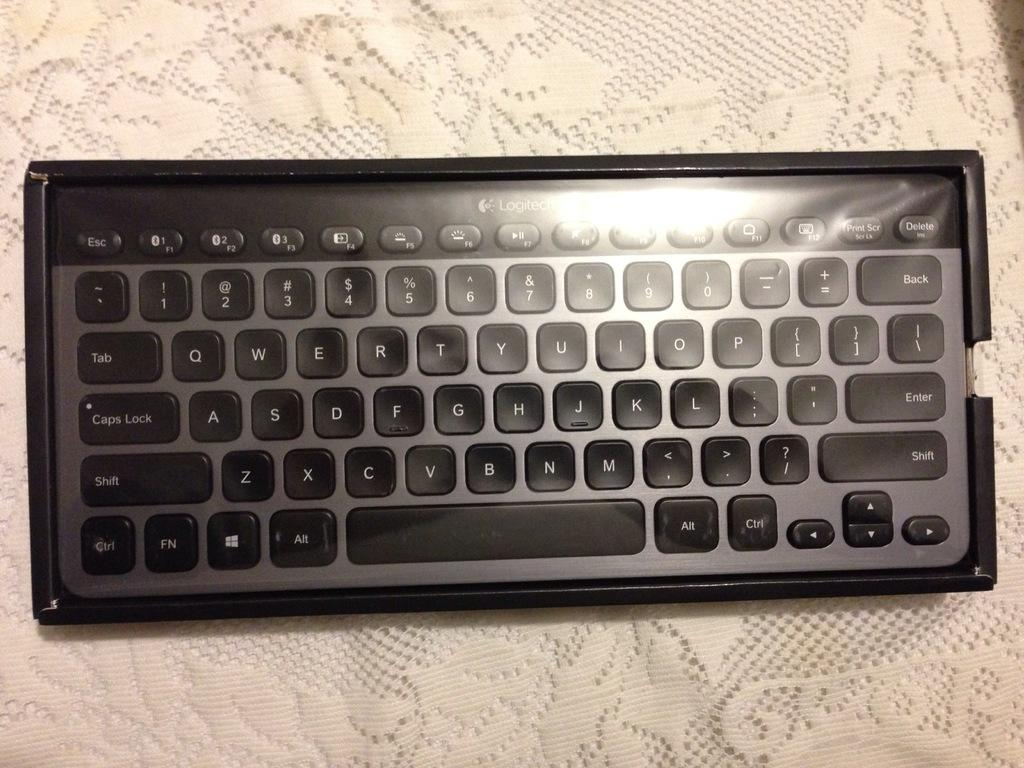<image>
Describe the image concisely. a Logitech keyboard is laying on a table 